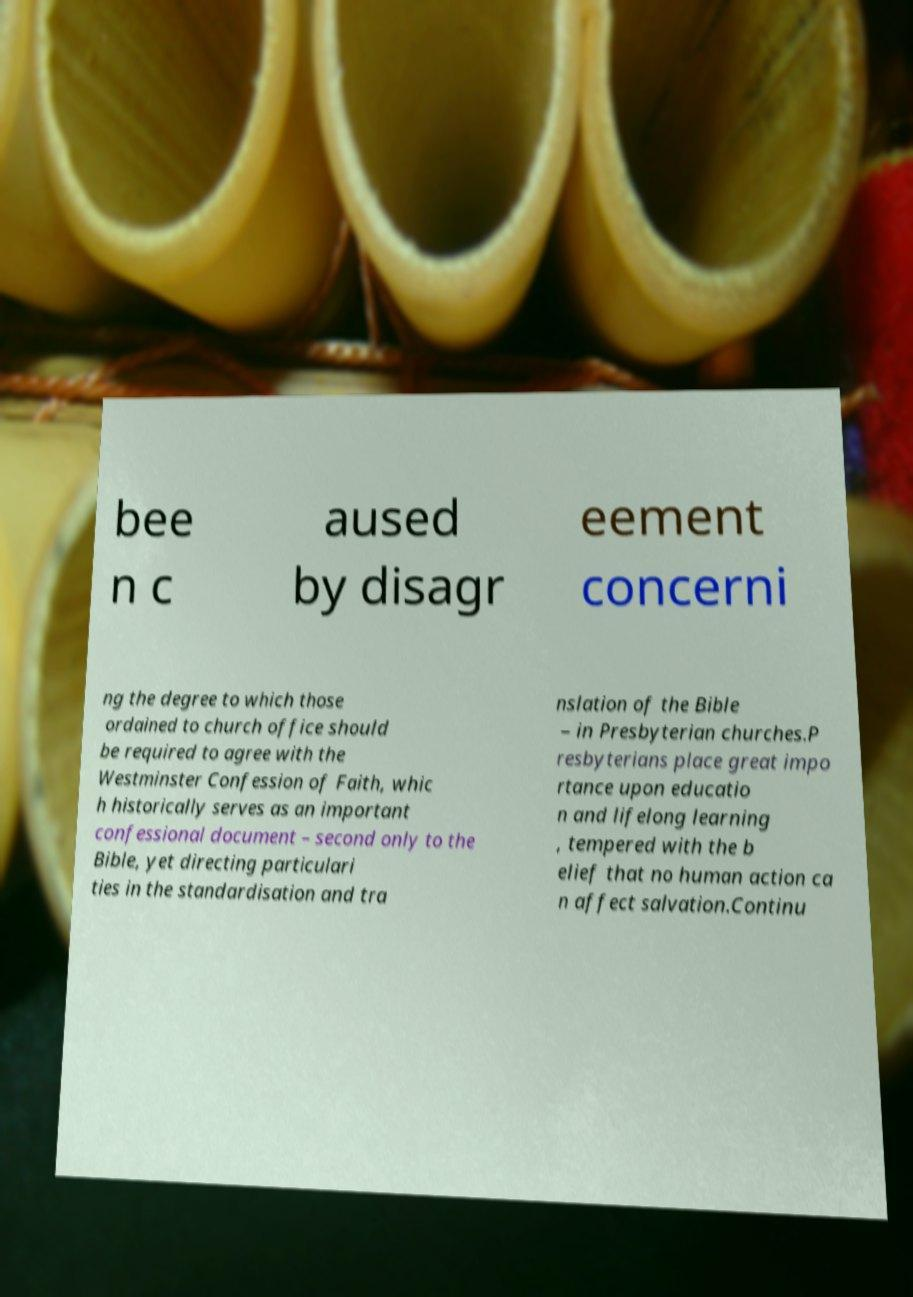Please read and relay the text visible in this image. What does it say? bee n c aused by disagr eement concerni ng the degree to which those ordained to church office should be required to agree with the Westminster Confession of Faith, whic h historically serves as an important confessional document – second only to the Bible, yet directing particulari ties in the standardisation and tra nslation of the Bible – in Presbyterian churches.P resbyterians place great impo rtance upon educatio n and lifelong learning , tempered with the b elief that no human action ca n affect salvation.Continu 